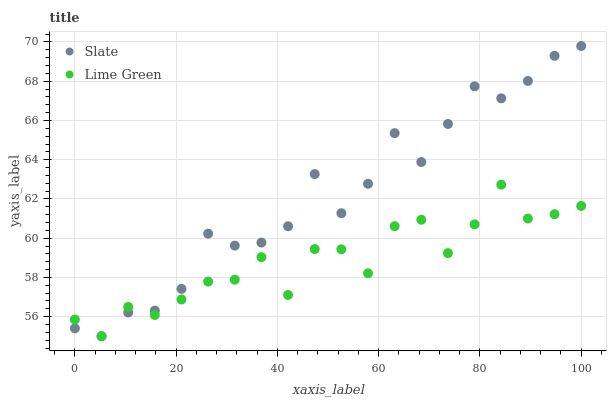Does Lime Green have the minimum area under the curve?
Answer yes or no. Yes. Does Slate have the maximum area under the curve?
Answer yes or no. Yes. Does Lime Green have the maximum area under the curve?
Answer yes or no. No. Is Slate the smoothest?
Answer yes or no. Yes. Is Lime Green the roughest?
Answer yes or no. Yes. Is Lime Green the smoothest?
Answer yes or no. No. Does Slate have the lowest value?
Answer yes or no. Yes. Does Slate have the highest value?
Answer yes or no. Yes. Does Lime Green have the highest value?
Answer yes or no. No. Does Lime Green intersect Slate?
Answer yes or no. Yes. Is Lime Green less than Slate?
Answer yes or no. No. Is Lime Green greater than Slate?
Answer yes or no. No. 